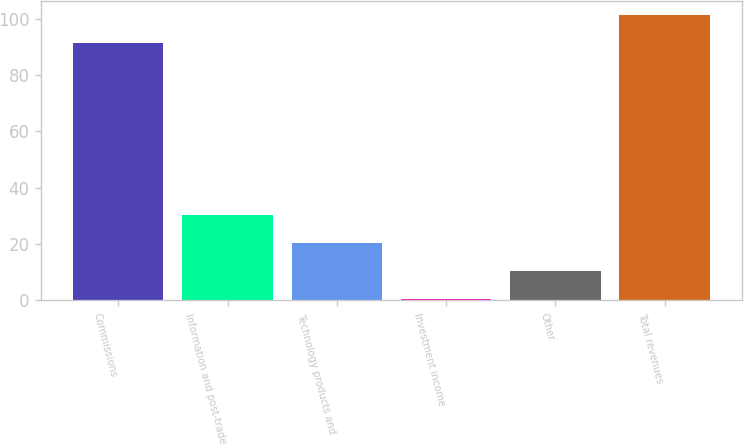<chart> <loc_0><loc_0><loc_500><loc_500><bar_chart><fcel>Commissions<fcel>Information and post-trade<fcel>Technology products and<fcel>Investment income<fcel>Other<fcel>Total revenues<nl><fcel>91.3<fcel>30.42<fcel>20.48<fcel>0.6<fcel>10.54<fcel>101.24<nl></chart> 